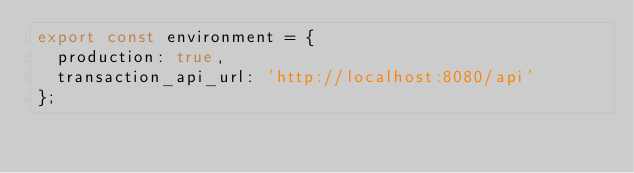<code> <loc_0><loc_0><loc_500><loc_500><_TypeScript_>export const environment = {
  production: true,
  transaction_api_url: 'http://localhost:8080/api'
};
</code> 